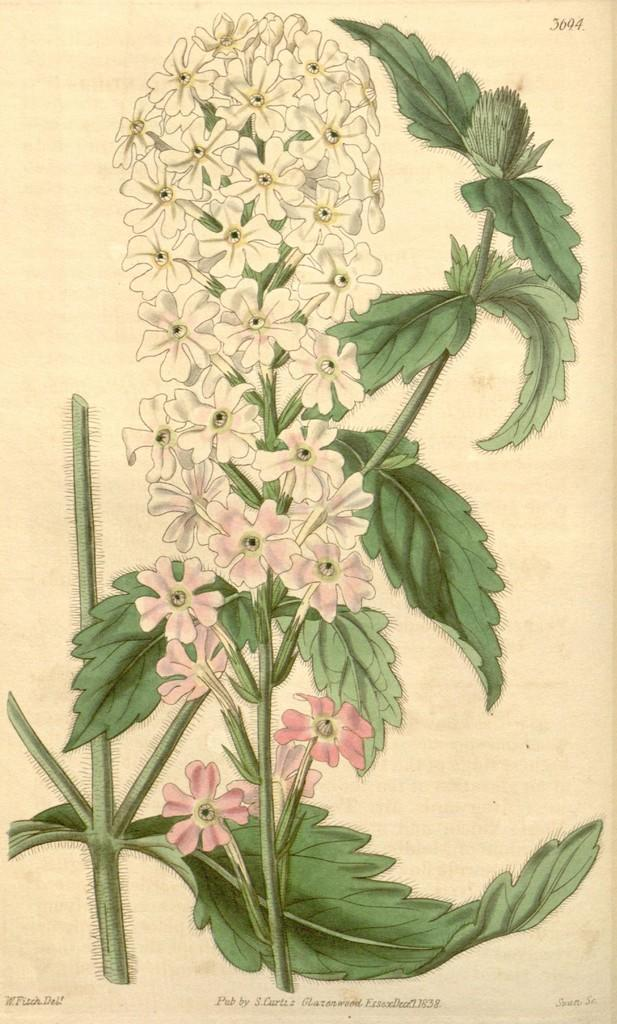What is depicted on the paper in the image? The paper contains a painting of a plant. What features of the plant can be seen in the painting? The plant has leaves and flowers in the painting. Is there any text on the paper in the image? Yes, there is writing on the image. How many family members are present in the image? There are no family members present in the image; it only contains a paper with a painting of a plant and writing. What day of the week is depicted in the image? There is no indication of a specific day of the week in the image. What type of metal can be seen in the image? There is no metal, such as copper, present in the image. 